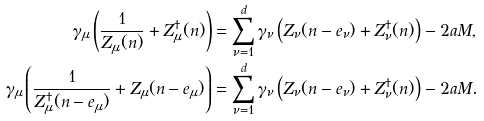Convert formula to latex. <formula><loc_0><loc_0><loc_500><loc_500>\gamma _ { \mu } \left ( \frac { 1 } { Z _ { \mu } ( n ) } + Z ^ { \dagger } _ { \mu } ( n ) \right ) & = \sum _ { \nu = 1 } ^ { d } \gamma _ { \nu } \left ( Z _ { \nu } ( n - e _ { \nu } ) + Z ^ { \dagger } _ { \nu } ( n ) \right ) - 2 a M , \\ \gamma _ { \mu } \left ( \frac { 1 } { Z ^ { \dagger } _ { \mu } ( n - e _ { \mu } ) } + Z _ { \mu } ( n - e _ { \mu } ) \right ) & = \sum _ { \nu = 1 } ^ { d } \gamma _ { \nu } \left ( Z _ { \nu } ( n - e _ { \nu } ) + Z ^ { \dagger } _ { \nu } ( n ) \right ) - 2 a M .</formula> 